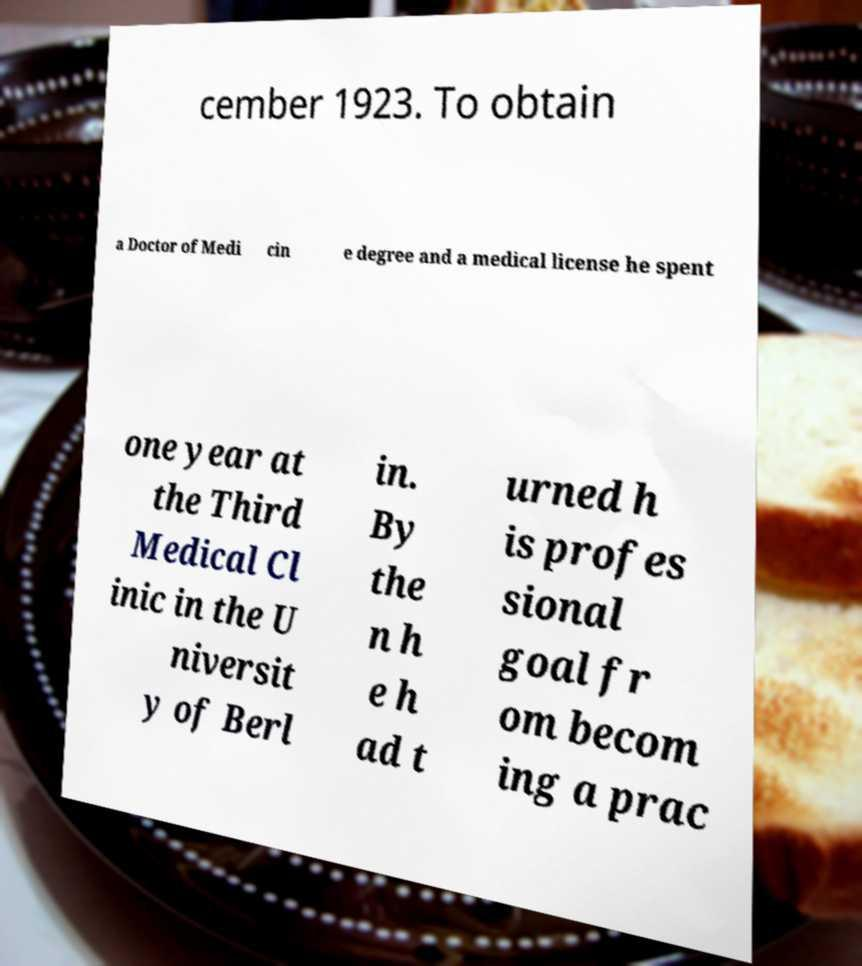What messages or text are displayed in this image? I need them in a readable, typed format. cember 1923. To obtain a Doctor of Medi cin e degree and a medical license he spent one year at the Third Medical Cl inic in the U niversit y of Berl in. By the n h e h ad t urned h is profes sional goal fr om becom ing a prac 